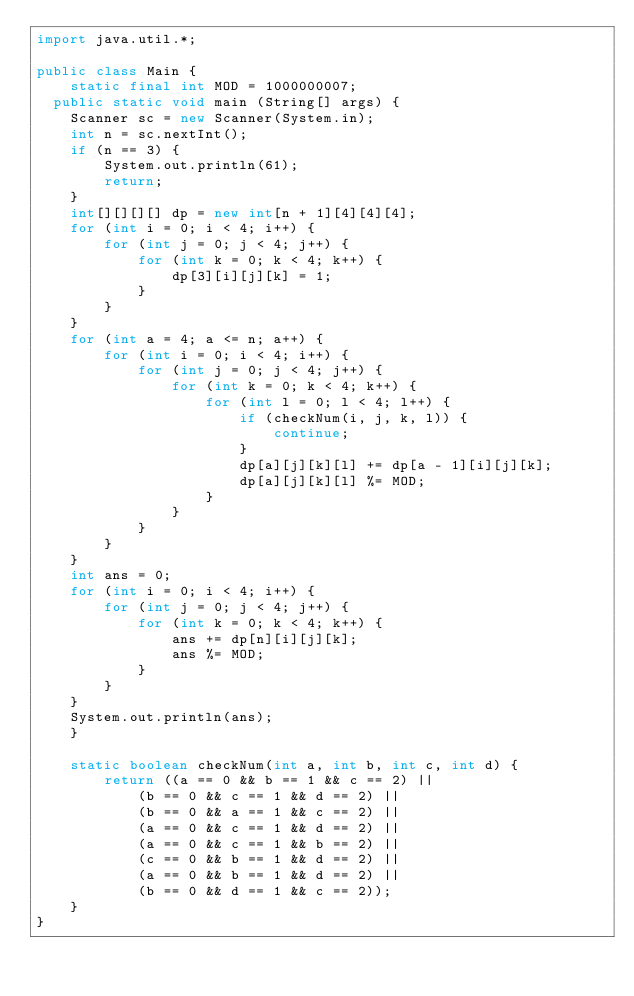<code> <loc_0><loc_0><loc_500><loc_500><_Java_>import java.util.*;

public class Main {
    static final int MOD = 1000000007;
	public static void main (String[] args) {
		Scanner sc = new Scanner(System.in);
		int n = sc.nextInt();
		if (n == 3) {
		    System.out.println(61);
		    return;
		}
		int[][][][] dp = new int[n + 1][4][4][4];
		for (int i = 0; i < 4; i++) {
		    for (int j = 0; j < 4; j++) {
		        for (int k = 0; k < 4; k++) {
		            dp[3][i][j][k] = 1;
		        }
		    }
		}
		for (int a = 4; a <= n; a++) {
    		for (int i = 0; i < 4; i++) {
    		    for (int j = 0; j < 4; j++) {
    		        for (int k = 0; k < 4; k++) {
    		            for (int l = 0; l < 4; l++) {
    		                if (checkNum(i, j, k, l)) {
    		                    continue;
    		                }
    		                dp[a][j][k][l] += dp[a - 1][i][j][k];
    		                dp[a][j][k][l] %= MOD;
    		            }
    		        }
    		    }
    		}
		}
		int ans = 0;
		for (int i = 0; i < 4; i++) {
		    for (int j = 0; j < 4; j++) {
		        for (int k = 0; k < 4; k++) {
		            ans += dp[n][i][j][k];
		            ans %= MOD;
		        }
		    }
		}
		System.out.println(ans);
    }
    
    static boolean checkNum(int a, int b, int c, int d) {
        return ((a == 0 && b == 1 && c == 2) ||
            (b == 0 && c == 1 && d == 2) ||
            (b == 0 && a == 1 && c == 2) ||
            (a == 0 && c == 1 && d == 2) ||
            (a == 0 && c == 1 && b == 2) ||
            (c == 0 && b == 1 && d == 2) ||
            (a == 0 && b == 1 && d == 2) ||
            (b == 0 && d == 1 && c == 2));
    }
}

</code> 